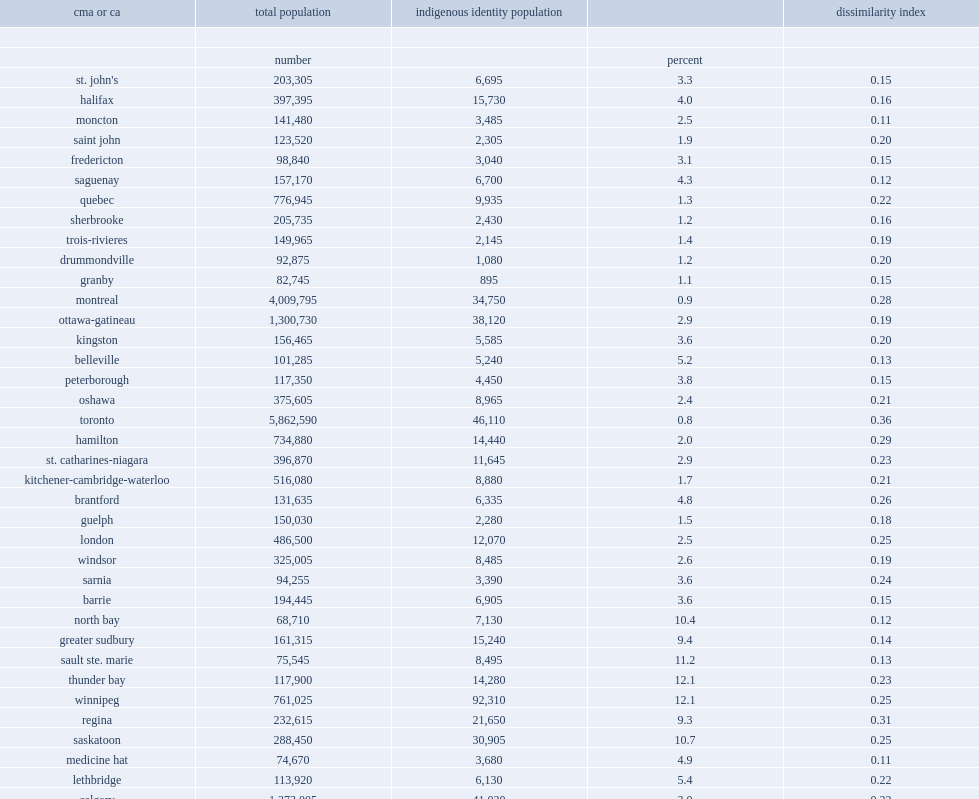Which city had third highest dissimilarity index among all cities? Hamilton. Which city has the lowest dissimilarity index among all cities? Grande prairie. Show any cities with a total population of less than 150,000. Grande prairie moncton medicine hat hamilton. How many percent of the popluation of toronto are indigenous people? 0.8. Which city has the lowest proportion of indigenous people among all the cities in this study? Toronto. How many percent of the popluation of toronto are indigenous people? 9.3. 